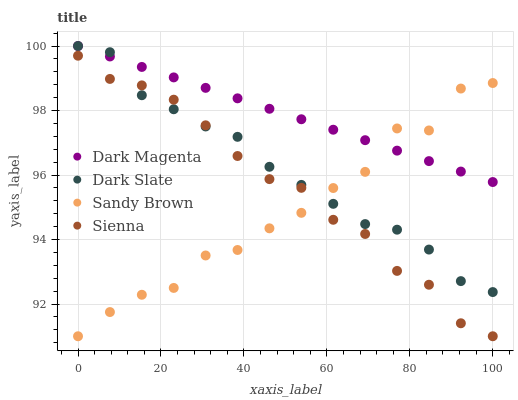Does Sandy Brown have the minimum area under the curve?
Answer yes or no. Yes. Does Dark Magenta have the maximum area under the curve?
Answer yes or no. Yes. Does Dark Slate have the minimum area under the curve?
Answer yes or no. No. Does Dark Slate have the maximum area under the curve?
Answer yes or no. No. Is Dark Magenta the smoothest?
Answer yes or no. Yes. Is Sandy Brown the roughest?
Answer yes or no. Yes. Is Dark Slate the smoothest?
Answer yes or no. No. Is Dark Slate the roughest?
Answer yes or no. No. Does Sienna have the lowest value?
Answer yes or no. Yes. Does Dark Slate have the lowest value?
Answer yes or no. No. Does Dark Magenta have the highest value?
Answer yes or no. Yes. Does Sandy Brown have the highest value?
Answer yes or no. No. Is Sienna less than Dark Magenta?
Answer yes or no. Yes. Is Dark Magenta greater than Sienna?
Answer yes or no. Yes. Does Sienna intersect Dark Slate?
Answer yes or no. Yes. Is Sienna less than Dark Slate?
Answer yes or no. No. Is Sienna greater than Dark Slate?
Answer yes or no. No. Does Sienna intersect Dark Magenta?
Answer yes or no. No. 